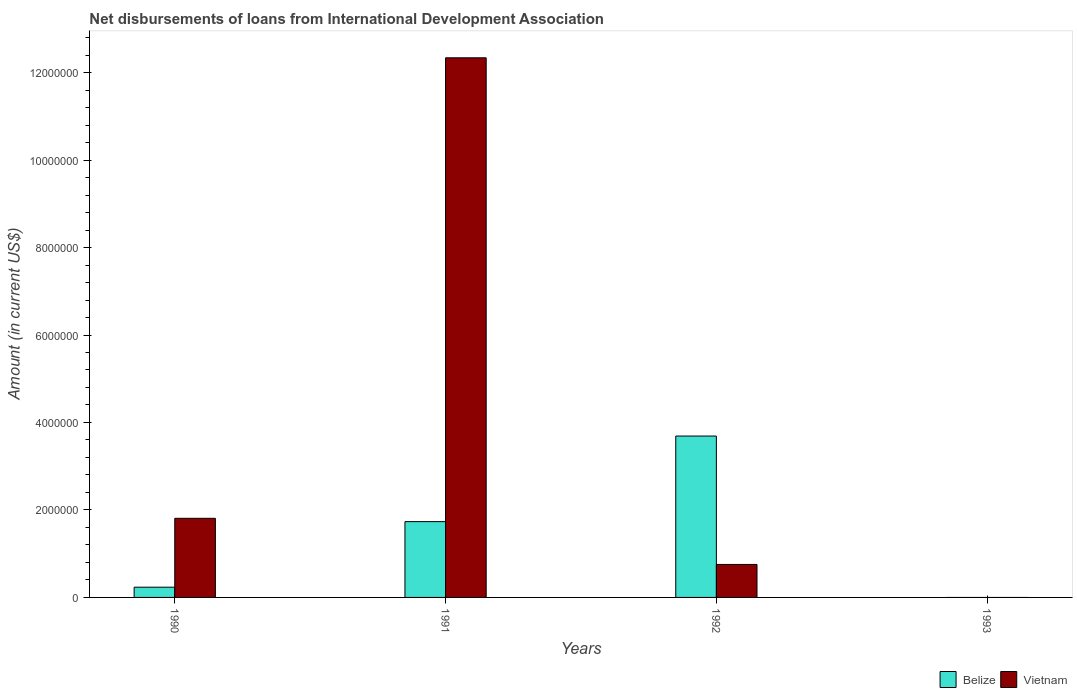How many different coloured bars are there?
Provide a short and direct response. 2. In how many cases, is the number of bars for a given year not equal to the number of legend labels?
Offer a very short reply. 1. What is the amount of loans disbursed in Vietnam in 1990?
Keep it short and to the point. 1.81e+06. Across all years, what is the maximum amount of loans disbursed in Belize?
Your answer should be compact. 3.69e+06. Across all years, what is the minimum amount of loans disbursed in Belize?
Your answer should be very brief. 0. In which year was the amount of loans disbursed in Vietnam maximum?
Give a very brief answer. 1991. What is the total amount of loans disbursed in Belize in the graph?
Offer a terse response. 5.66e+06. What is the difference between the amount of loans disbursed in Belize in 1990 and that in 1991?
Offer a terse response. -1.50e+06. What is the difference between the amount of loans disbursed in Belize in 1992 and the amount of loans disbursed in Vietnam in 1991?
Offer a terse response. -8.65e+06. What is the average amount of loans disbursed in Vietnam per year?
Provide a succinct answer. 3.73e+06. In the year 1992, what is the difference between the amount of loans disbursed in Belize and amount of loans disbursed in Vietnam?
Make the answer very short. 2.94e+06. What is the ratio of the amount of loans disbursed in Belize in 1991 to that in 1992?
Provide a succinct answer. 0.47. Is the amount of loans disbursed in Belize in 1990 less than that in 1992?
Your answer should be very brief. Yes. What is the difference between the highest and the second highest amount of loans disbursed in Vietnam?
Provide a succinct answer. 1.05e+07. What is the difference between the highest and the lowest amount of loans disbursed in Belize?
Make the answer very short. 3.69e+06. In how many years, is the amount of loans disbursed in Vietnam greater than the average amount of loans disbursed in Vietnam taken over all years?
Provide a short and direct response. 1. Is the sum of the amount of loans disbursed in Belize in 1990 and 1991 greater than the maximum amount of loans disbursed in Vietnam across all years?
Offer a very short reply. No. How many years are there in the graph?
Give a very brief answer. 4. What is the difference between two consecutive major ticks on the Y-axis?
Your answer should be very brief. 2.00e+06. Does the graph contain grids?
Your response must be concise. No. How are the legend labels stacked?
Your answer should be compact. Horizontal. What is the title of the graph?
Give a very brief answer. Net disbursements of loans from International Development Association. Does "Equatorial Guinea" appear as one of the legend labels in the graph?
Offer a very short reply. No. What is the Amount (in current US$) of Belize in 1990?
Offer a very short reply. 2.34e+05. What is the Amount (in current US$) in Vietnam in 1990?
Provide a short and direct response. 1.81e+06. What is the Amount (in current US$) in Belize in 1991?
Ensure brevity in your answer.  1.73e+06. What is the Amount (in current US$) in Vietnam in 1991?
Your answer should be compact. 1.23e+07. What is the Amount (in current US$) of Belize in 1992?
Your answer should be compact. 3.69e+06. What is the Amount (in current US$) in Vietnam in 1992?
Your response must be concise. 7.54e+05. What is the Amount (in current US$) in Belize in 1993?
Your answer should be very brief. 0. What is the Amount (in current US$) in Vietnam in 1993?
Your response must be concise. 0. Across all years, what is the maximum Amount (in current US$) in Belize?
Your answer should be compact. 3.69e+06. Across all years, what is the maximum Amount (in current US$) in Vietnam?
Make the answer very short. 1.23e+07. Across all years, what is the minimum Amount (in current US$) of Vietnam?
Provide a succinct answer. 0. What is the total Amount (in current US$) in Belize in the graph?
Offer a very short reply. 5.66e+06. What is the total Amount (in current US$) in Vietnam in the graph?
Offer a very short reply. 1.49e+07. What is the difference between the Amount (in current US$) of Belize in 1990 and that in 1991?
Offer a terse response. -1.50e+06. What is the difference between the Amount (in current US$) of Vietnam in 1990 and that in 1991?
Keep it short and to the point. -1.05e+07. What is the difference between the Amount (in current US$) in Belize in 1990 and that in 1992?
Provide a short and direct response. -3.46e+06. What is the difference between the Amount (in current US$) in Vietnam in 1990 and that in 1992?
Provide a short and direct response. 1.06e+06. What is the difference between the Amount (in current US$) of Belize in 1991 and that in 1992?
Offer a very short reply. -1.96e+06. What is the difference between the Amount (in current US$) of Vietnam in 1991 and that in 1992?
Your response must be concise. 1.16e+07. What is the difference between the Amount (in current US$) in Belize in 1990 and the Amount (in current US$) in Vietnam in 1991?
Offer a very short reply. -1.21e+07. What is the difference between the Amount (in current US$) in Belize in 1990 and the Amount (in current US$) in Vietnam in 1992?
Your answer should be very brief. -5.20e+05. What is the difference between the Amount (in current US$) in Belize in 1991 and the Amount (in current US$) in Vietnam in 1992?
Your response must be concise. 9.79e+05. What is the average Amount (in current US$) in Belize per year?
Your answer should be very brief. 1.41e+06. What is the average Amount (in current US$) in Vietnam per year?
Your response must be concise. 3.73e+06. In the year 1990, what is the difference between the Amount (in current US$) in Belize and Amount (in current US$) in Vietnam?
Keep it short and to the point. -1.58e+06. In the year 1991, what is the difference between the Amount (in current US$) of Belize and Amount (in current US$) of Vietnam?
Offer a very short reply. -1.06e+07. In the year 1992, what is the difference between the Amount (in current US$) of Belize and Amount (in current US$) of Vietnam?
Keep it short and to the point. 2.94e+06. What is the ratio of the Amount (in current US$) of Belize in 1990 to that in 1991?
Provide a succinct answer. 0.14. What is the ratio of the Amount (in current US$) of Vietnam in 1990 to that in 1991?
Provide a short and direct response. 0.15. What is the ratio of the Amount (in current US$) in Belize in 1990 to that in 1992?
Offer a terse response. 0.06. What is the ratio of the Amount (in current US$) in Vietnam in 1990 to that in 1992?
Ensure brevity in your answer.  2.4. What is the ratio of the Amount (in current US$) of Belize in 1991 to that in 1992?
Offer a terse response. 0.47. What is the ratio of the Amount (in current US$) in Vietnam in 1991 to that in 1992?
Give a very brief answer. 16.36. What is the difference between the highest and the second highest Amount (in current US$) in Belize?
Offer a terse response. 1.96e+06. What is the difference between the highest and the second highest Amount (in current US$) in Vietnam?
Make the answer very short. 1.05e+07. What is the difference between the highest and the lowest Amount (in current US$) of Belize?
Give a very brief answer. 3.69e+06. What is the difference between the highest and the lowest Amount (in current US$) of Vietnam?
Ensure brevity in your answer.  1.23e+07. 